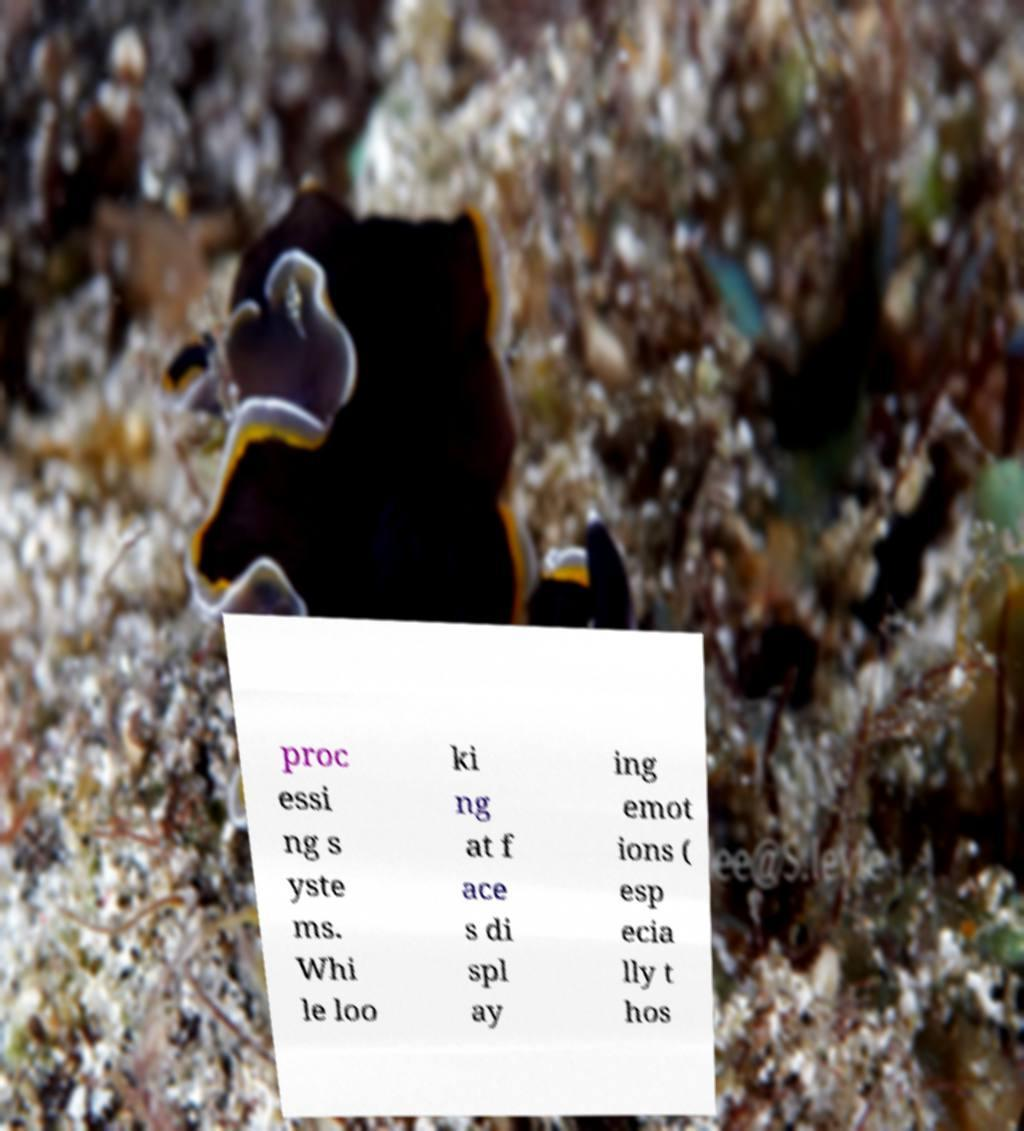Can you read and provide the text displayed in the image?This photo seems to have some interesting text. Can you extract and type it out for me? proc essi ng s yste ms. Whi le loo ki ng at f ace s di spl ay ing emot ions ( esp ecia lly t hos 